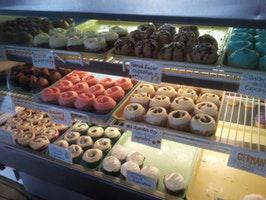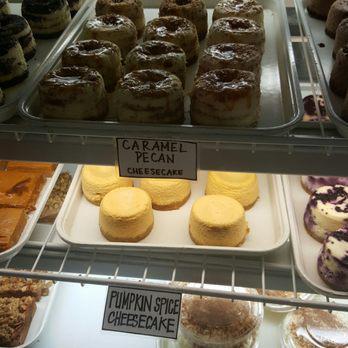The first image is the image on the left, the second image is the image on the right. Examine the images to the left and right. Is the description "One image shows a line of desserts displayed under glass on silver pedestals atop a counter, and the other image shows a glass display front that includes pink, yellow, white and brown frosted cupcakes." accurate? Answer yes or no. No. The first image is the image on the left, the second image is the image on the right. Analyze the images presented: Is the assertion "There are lemon pastries on the middle shelf." valid? Answer yes or no. No. 